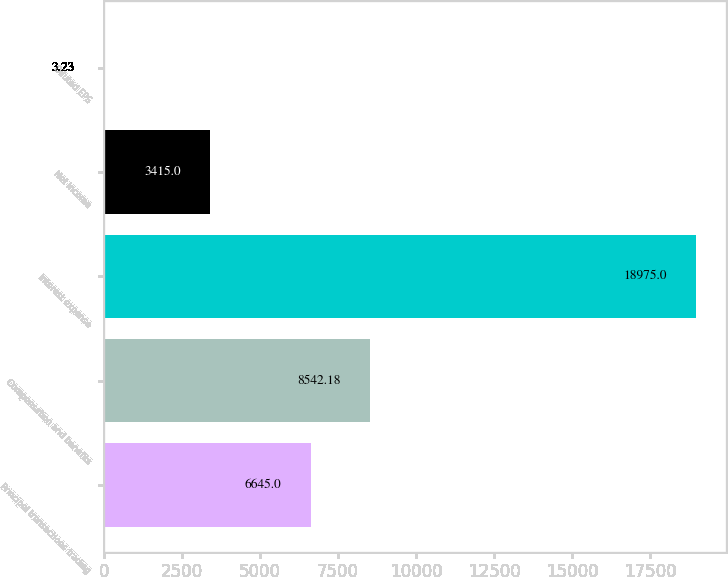Convert chart. <chart><loc_0><loc_0><loc_500><loc_500><bar_chart><fcel>Principal transactions trading<fcel>Compensation and benefits<fcel>Interest expense<fcel>Net income<fcel>Diluted EPS<nl><fcel>6645<fcel>8542.18<fcel>18975<fcel>3415<fcel>3.23<nl></chart> 